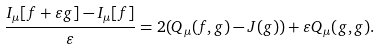<formula> <loc_0><loc_0><loc_500><loc_500>\frac { I _ { \mu } [ f + \varepsilon g ] - I _ { \mu } [ f ] } { \varepsilon } = 2 ( Q _ { \mu } ( f , g ) - J ( g ) ) + \varepsilon Q _ { \mu } ( g , g ) .</formula> 